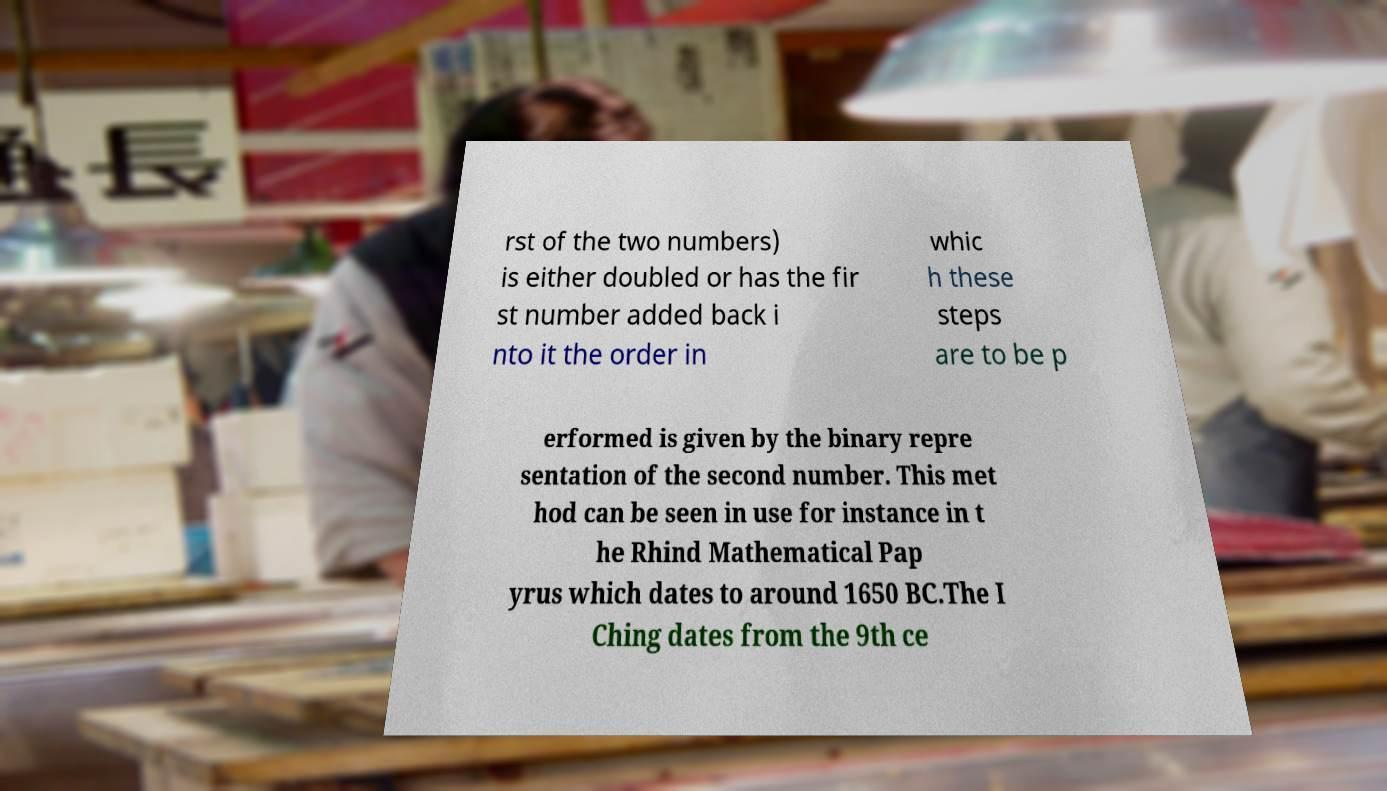Please read and relay the text visible in this image. What does it say? rst of the two numbers) is either doubled or has the fir st number added back i nto it the order in whic h these steps are to be p erformed is given by the binary repre sentation of the second number. This met hod can be seen in use for instance in t he Rhind Mathematical Pap yrus which dates to around 1650 BC.The I Ching dates from the 9th ce 